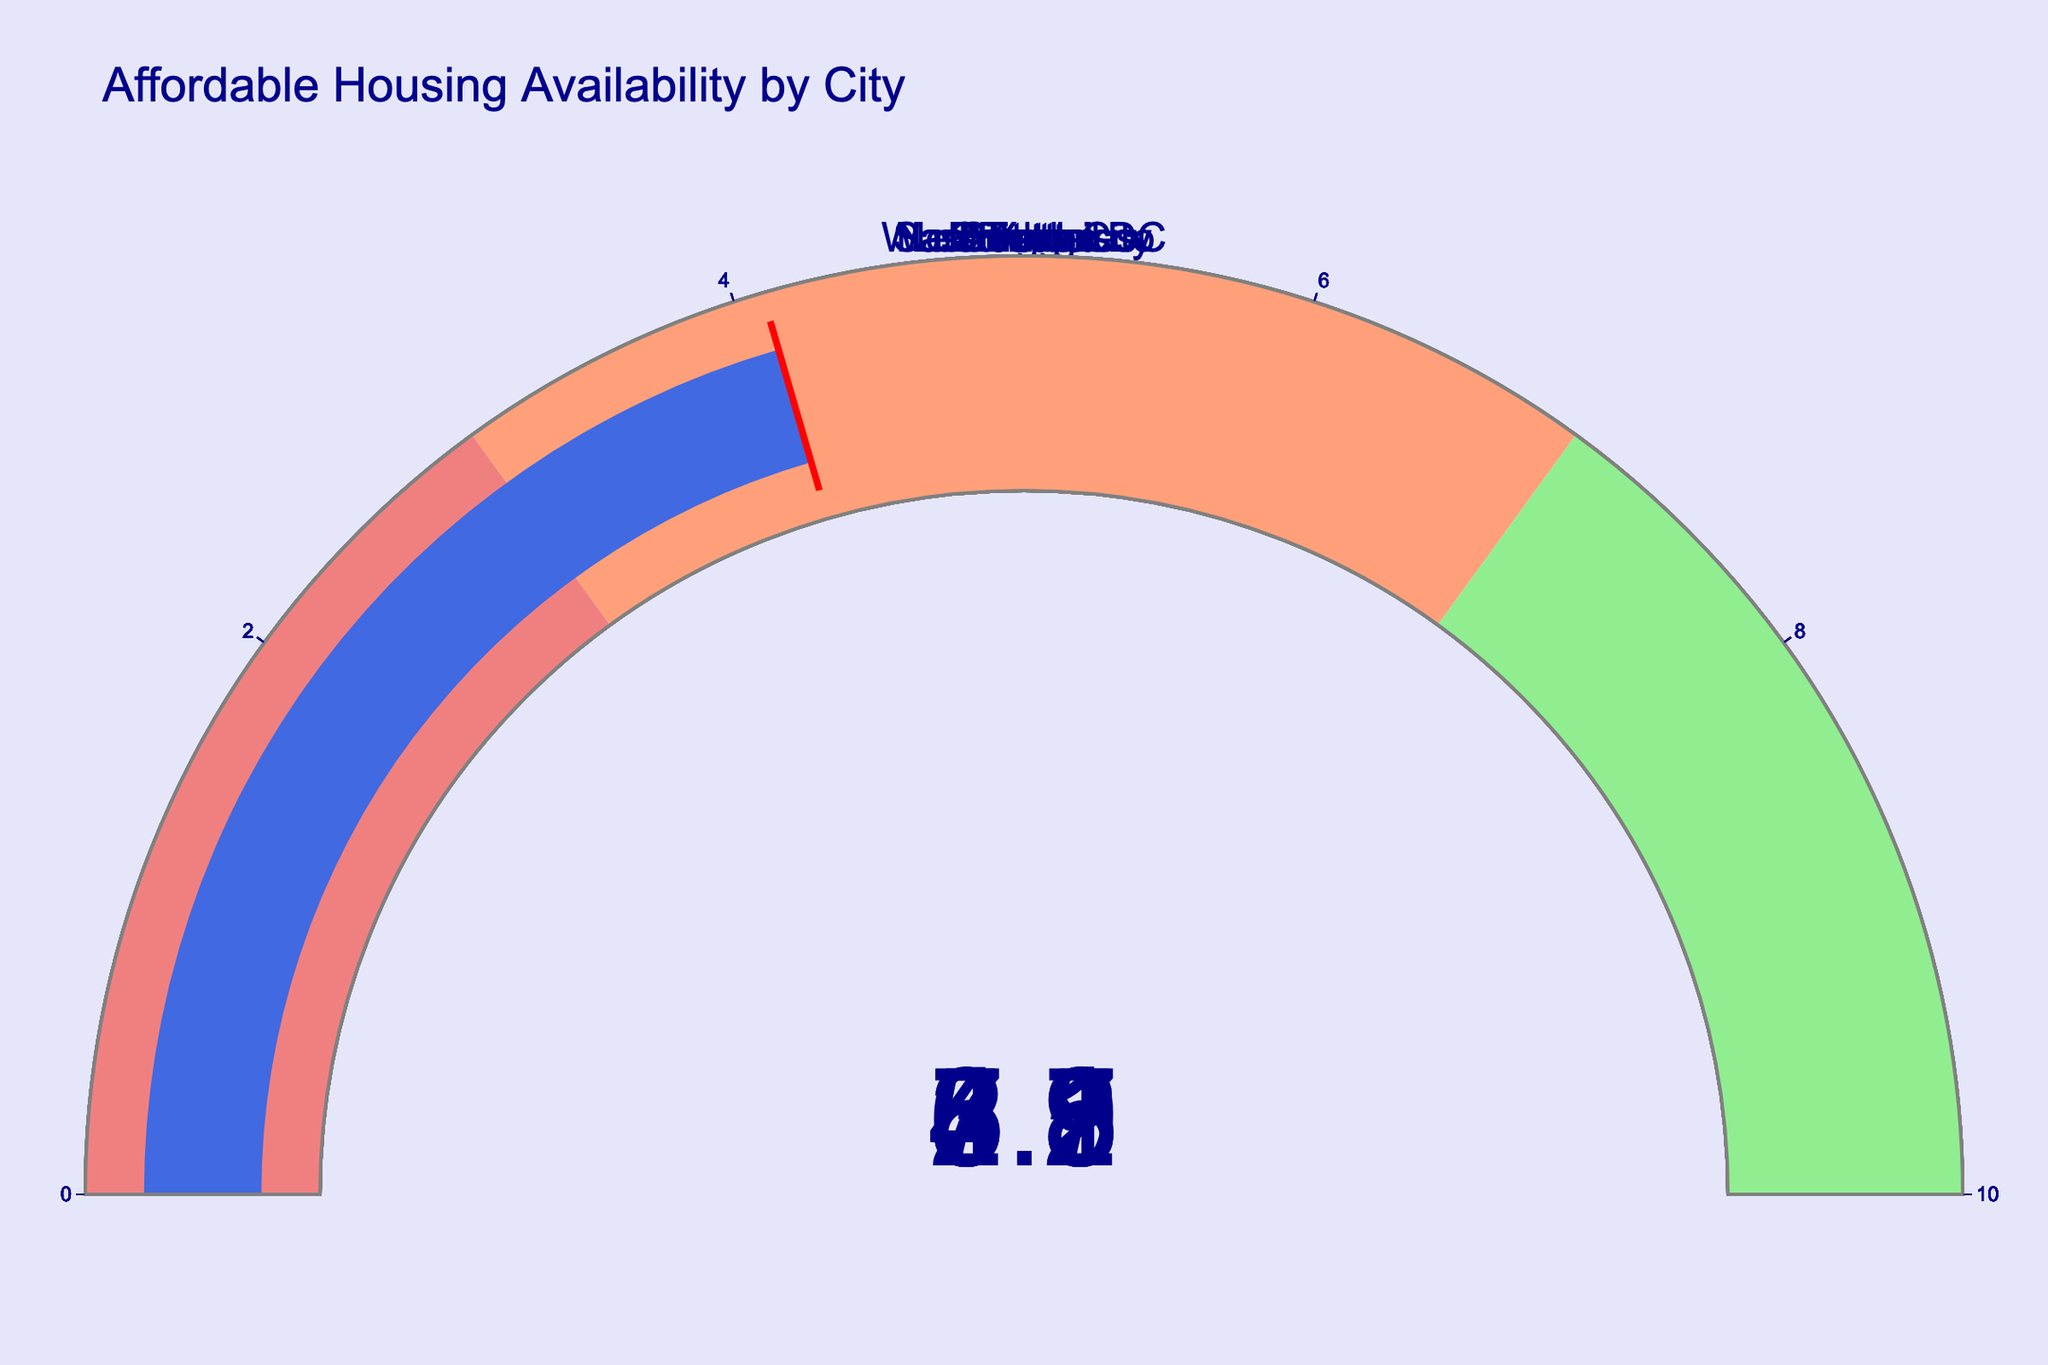What's the title of the figure? The title is usually displayed at the top of the figure. Here, the title reads "Affordable Housing Availability by City," which indicates the general subject of all the data presented in the figure.
Answer: Affordable Housing Availability by City Which city has the highest percentage of affordable housing? Look at each gauge chart and identify the highest value displayed. Boston has the highest value of 7.3%.
Answer: Boston How many cities have an affordable housing percentage above 5%? To determine this, count the number of cities where the gauge shows a value greater than 5%. The cities are Chicago, Seattle, Boston, and Atlanta.
Answer: 4 Which cities fall into the "lightcoral" range for affordable housing availability? The "lightcoral" color range is from 0% to 3%. Identify the cities within this range: Los Angeles (3.2%) and San Francisco (2.9%).
Answer: Los Angeles, San Francisco What's the difference in affordable housing percentage between Seattle and San Francisco? Subtract the percentage of San Francisco from that of Seattle to find the difference: 6.1% - 2.9% = 3.2%.
Answer: 3.2% Which city has a percentage closest to the median value of all cities? First, list all percentages and find the median: 2.9, 3.2, 3.8, 4.1, 4.5, 4.8, 5.2, 5.7, 6.1, 7.3. The median is between 4.5 and 4.8, so the city closest to these values is Washington DC (4.5%).
Answer: Washington DC What is the average percentage of affordable housing across all cities? Add all percentages and divide by the number of cities: (4.8+3.2+5.7+2.9+6.1+7.3+4.5+3.8+5.2+4.1)/10 = 4.76%.
Answer: 4.76% Which city has the lowest percentage of affordable housing? Identify the gauge with the lowest value. San Francisco has the lowest percentage at 2.9%.
Answer: San Francisco Are there more cities with affordable housing percentages above or below 5%? Count the number of cities above 5% (Chicago, Seattle, Boston, Atlanta) and below 5% (New York City, Los Angeles, San Francisco, Washington DC, Denver, Portland). There are more cities below 5%.
Answer: Below Which gauge charts fall in the "lightgreen" range? The "lightgreen" color range is from 7% to 10%. Identify the cities within this range: Boston is in the "lightgreen" range with a percentage of 7.3%.
Answer: Boston 